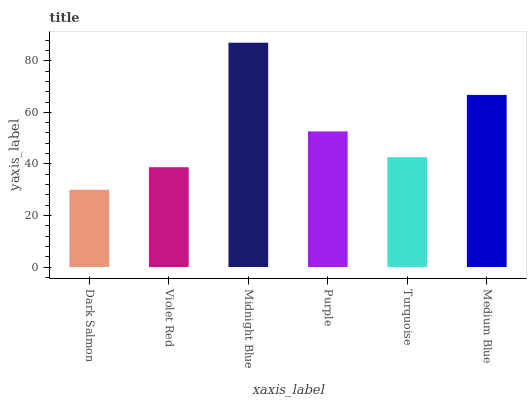Is Violet Red the minimum?
Answer yes or no. No. Is Violet Red the maximum?
Answer yes or no. No. Is Violet Red greater than Dark Salmon?
Answer yes or no. Yes. Is Dark Salmon less than Violet Red?
Answer yes or no. Yes. Is Dark Salmon greater than Violet Red?
Answer yes or no. No. Is Violet Red less than Dark Salmon?
Answer yes or no. No. Is Purple the high median?
Answer yes or no. Yes. Is Turquoise the low median?
Answer yes or no. Yes. Is Violet Red the high median?
Answer yes or no. No. Is Violet Red the low median?
Answer yes or no. No. 